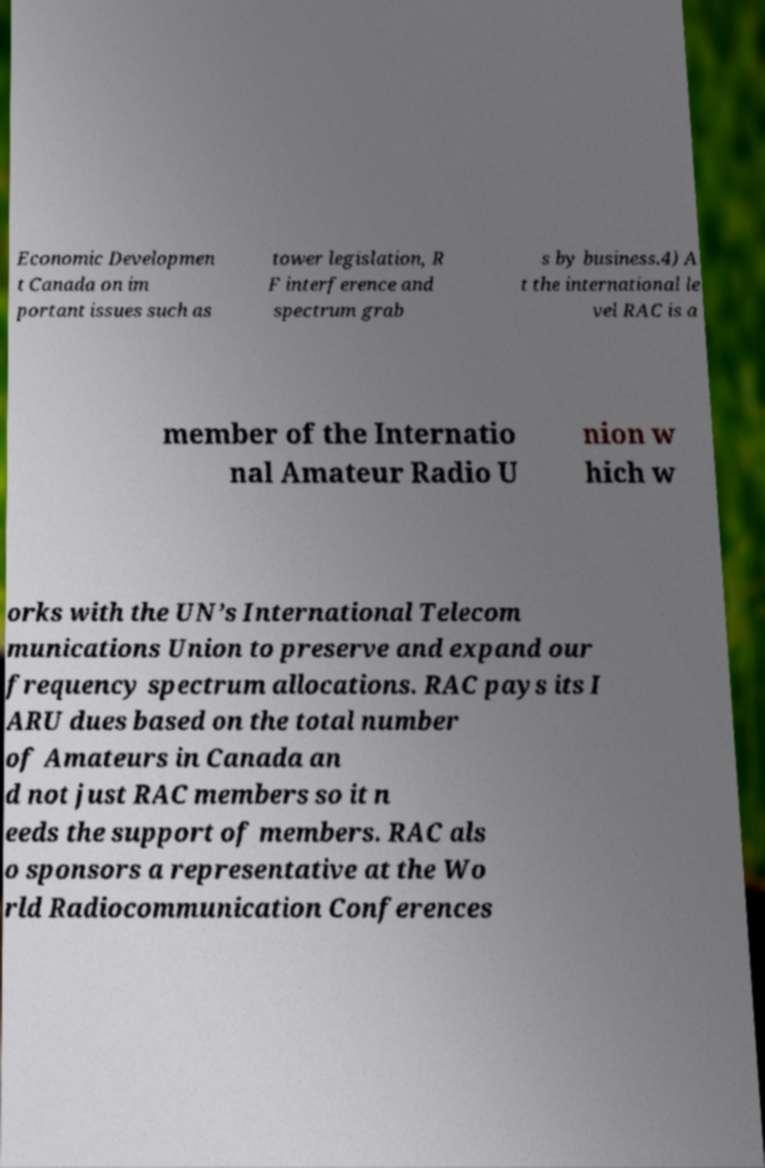I need the written content from this picture converted into text. Can you do that? Economic Developmen t Canada on im portant issues such as tower legislation, R F interference and spectrum grab s by business.4) A t the international le vel RAC is a member of the Internatio nal Amateur Radio U nion w hich w orks with the UN’s International Telecom munications Union to preserve and expand our frequency spectrum allocations. RAC pays its I ARU dues based on the total number of Amateurs in Canada an d not just RAC members so it n eeds the support of members. RAC als o sponsors a representative at the Wo rld Radiocommunication Conferences 